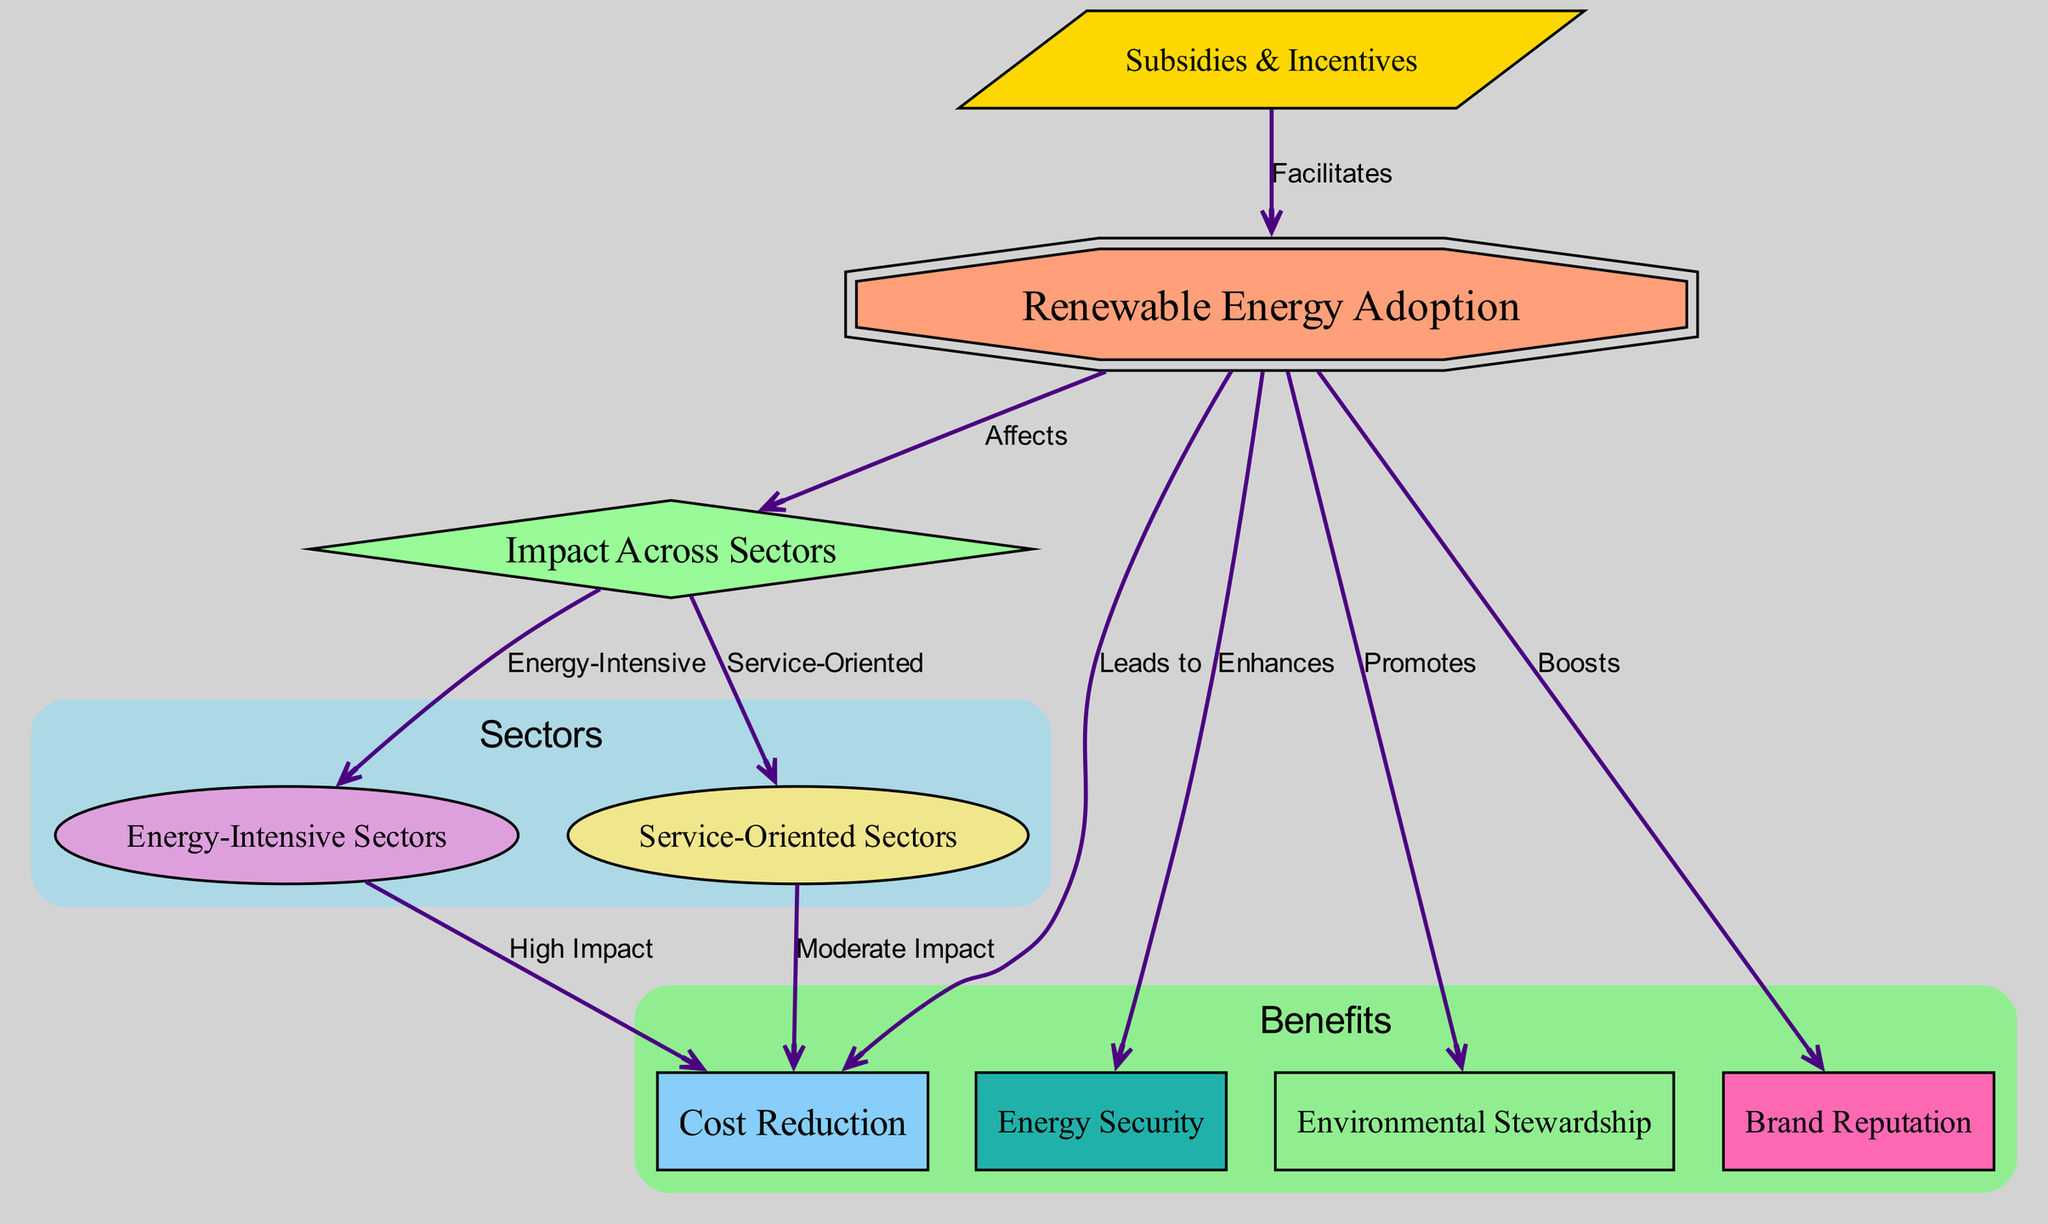What is the main focus of the diagram? The diagram's main focus, as indicated by the prominent node at the top, is "Renewable Energy Adoption," which serves as the starting point for the relationships displayed.
Answer: Renewable Energy Adoption How many sectors are highlighted in the diagram? The diagram explicitly shows two sectors: "Energy-Intensive Sectors" and "Service-Oriented Sectors," which can be counted from the connections and node labels.
Answer: 2 What effect does renewable energy adoption have on cost reduction in energy-intensive sectors? The edge connecting "sector_energy_intensive" and "cost_reduction" specifies that renewable energy adoption leads to a "High Impact" on cost reduction in energy-intensive sectors.
Answer: High Impact Which node is directly connected to 'Subsidies & Incentives'? The only connection leading out from 'Subsidies & Incentives' is directed towards 'Renewable Energy Adoption,' showing it facilitates adoption.
Answer: Renewable Energy Adoption How does renewable energy adoption influence brand reputation? The diagram illustrates that renewing energy adoption "Boosts" brand reputation, emphasizing a positive relationship in the benefits section.
Answer: Boosts What type of sectors has a moderate impact on cost reduction due to renewable energy adoption? The diagram indicates that "Service-Oriented Sectors" experience a "Moderate Impact" on cost reduction, as denoted by the edge leading to "cost_reduction."
Answer: Moderate Impact What benefits are associated with renewable energy adoption? The diagram includes four distinct benefits related to renewable energy adoption: cost reduction, energy security, environmental stewardship, and brand reputation, which can be listed from the benefits section.
Answer: Cost reduction, energy security, environmental stewardship, brand reputation Which node indicates that renewable energy adoption enhances energy security? The diagram directly shows an edge labeled "Enhances" pointing from "Renewable Energy Adoption" to "Energy Security," which clearly denotes the relationship.
Answer: Energy Security In what way do subsidies and incentives impact renewable energy adoption? The edge from "Subsidies & Incentives" to "Renewable Energy Adoption" is labeled "Facilitates," indicating that these financial supports help in promoting adoption.
Answer: Facilitates 